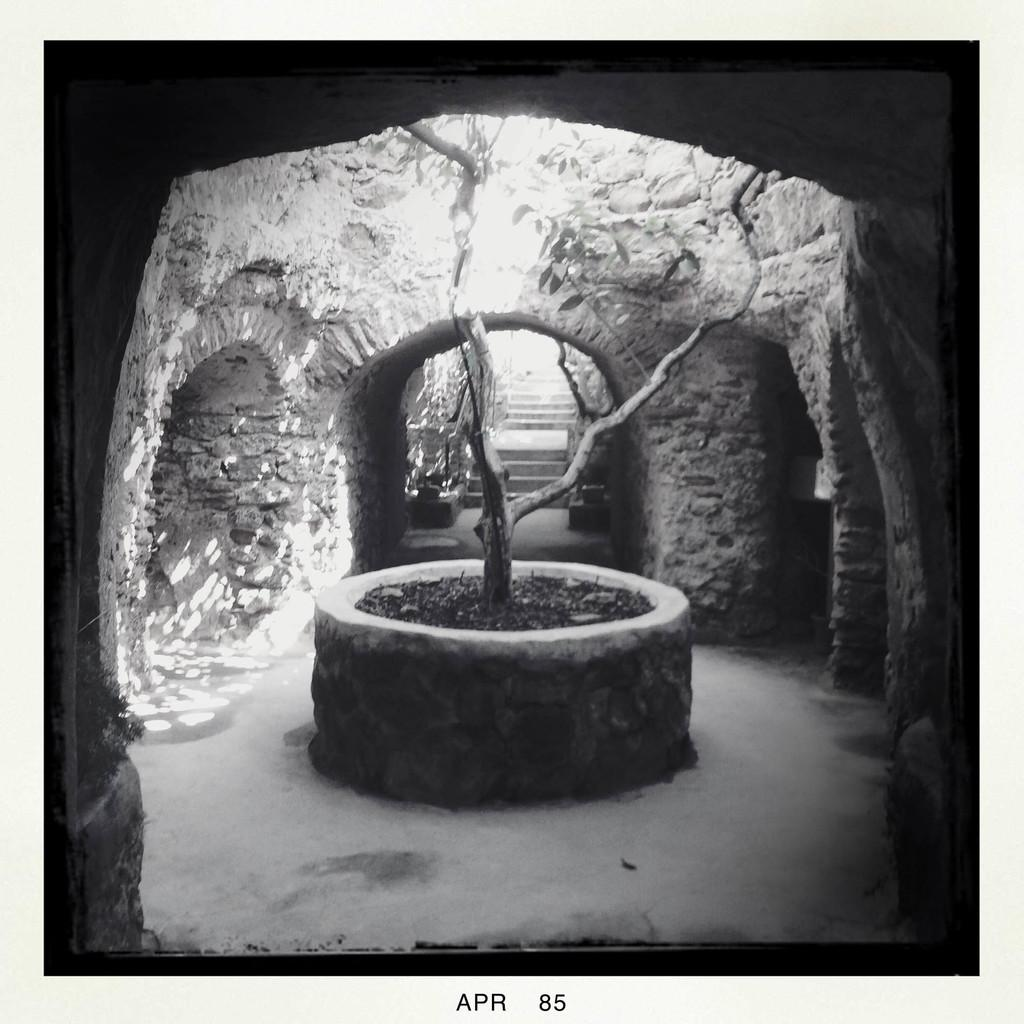What is the main subject of the image? The main subject of the image is a tunnel construction. Are there any natural elements present near the tunnel construction? Yes, a dried plant is present near the tunnel construction. What type of structures can be seen in the image? There are walls visible in the image. What architectural feature can be seen in the background of the image? There are steps in the background of the image. Can you see a tiger walking through the fog in the image? No, there is no tiger or fog present in the image. 